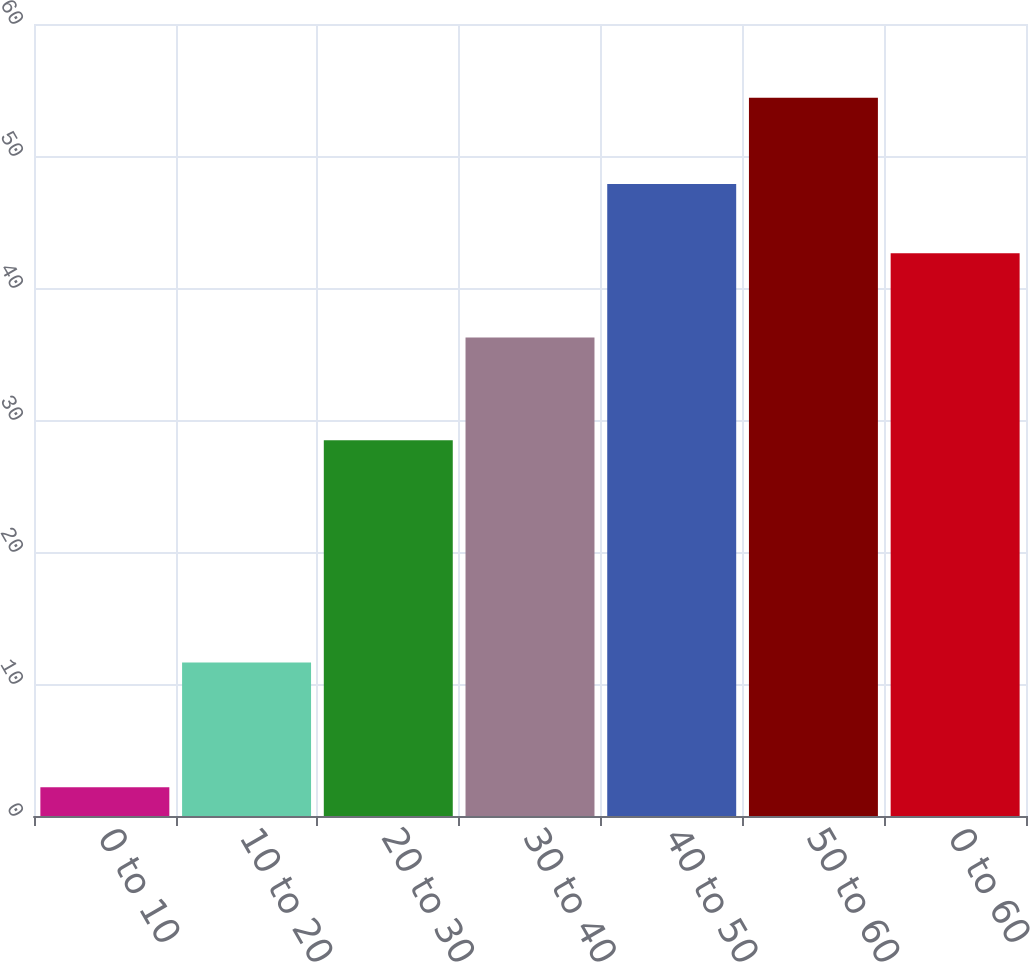Convert chart. <chart><loc_0><loc_0><loc_500><loc_500><bar_chart><fcel>0 to 10<fcel>10 to 20<fcel>20 to 30<fcel>30 to 40<fcel>40 to 50<fcel>50 to 60<fcel>0 to 60<nl><fcel>2.17<fcel>11.62<fcel>28.47<fcel>36.25<fcel>47.87<fcel>54.42<fcel>42.64<nl></chart> 